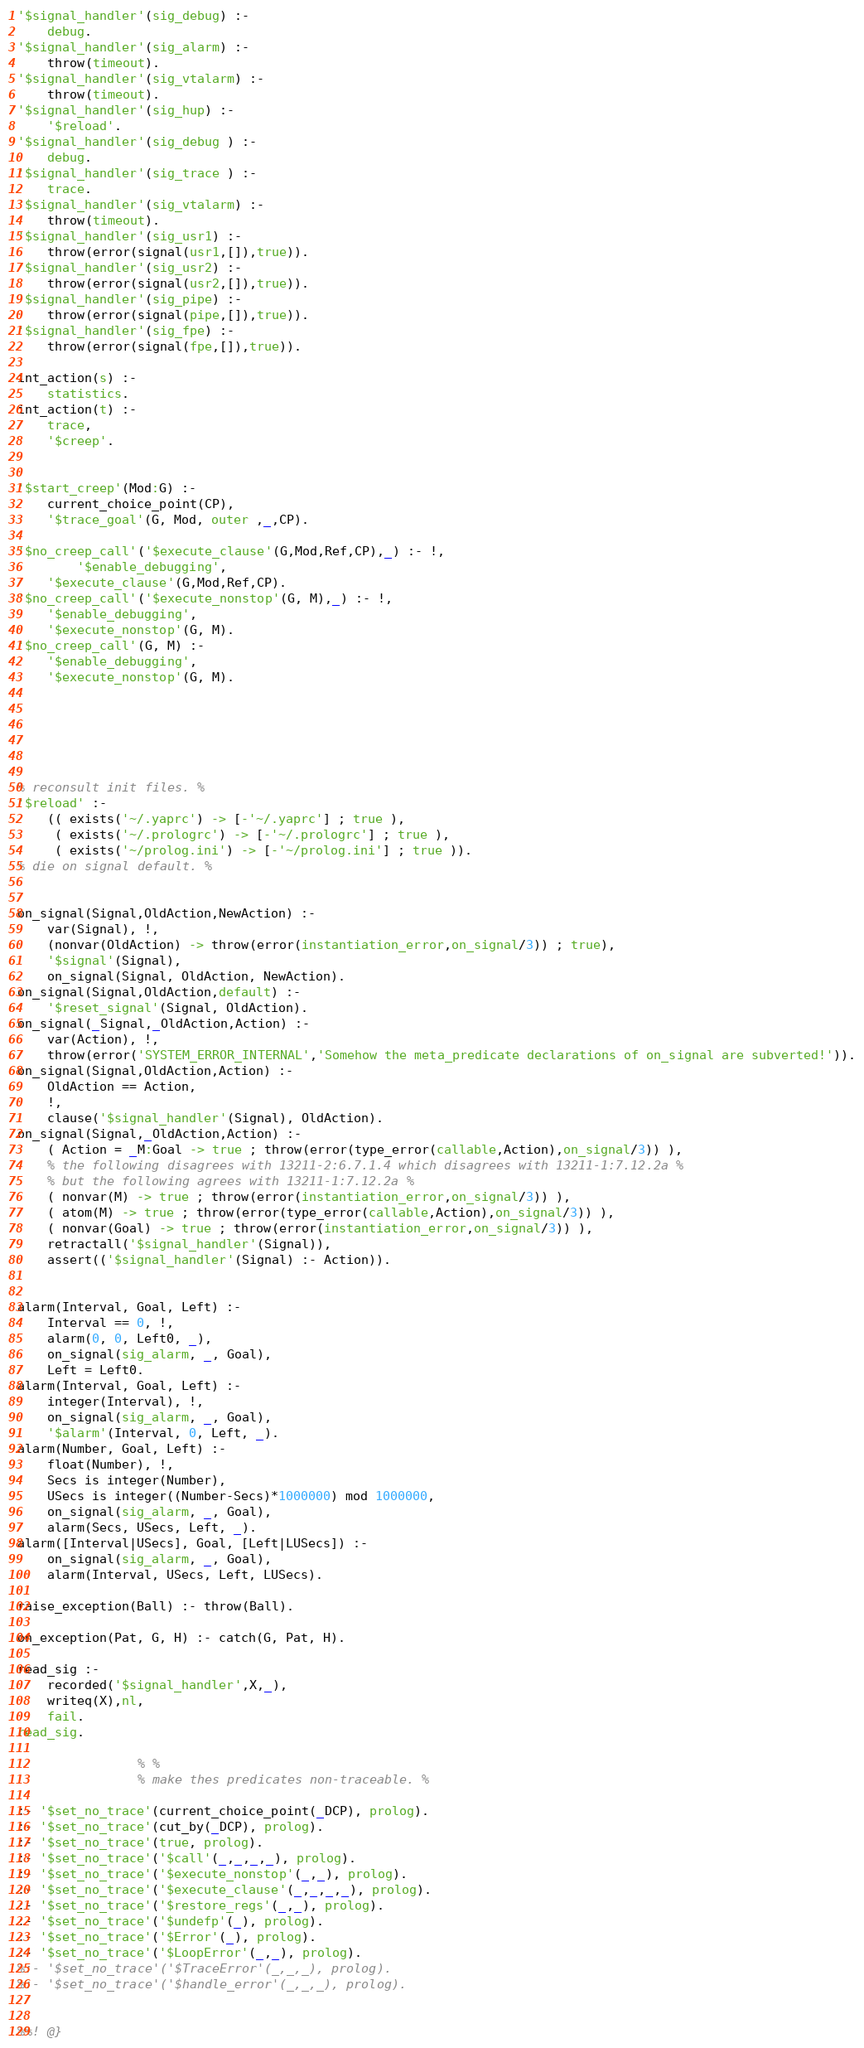<code> <loc_0><loc_0><loc_500><loc_500><_Prolog_>'$signal_handler'(sig_debug) :-
	debug.
'$signal_handler'(sig_alarm) :-
    throw(timeout).
'$signal_handler'(sig_vtalarm) :-
    throw(timeout).
'$signal_handler'(sig_hup) :-
    '$reload'.
'$signal_handler'(sig_debug ) :-
	debug.
'$signal_handler'(sig_trace ) :-
	trace.
'$signal_handler'(sig_vtalarm) :-
    throw(timeout).
'$signal_handler'(sig_usr1) :-
    throw(error(signal(usr1,[]),true)).
'$signal_handler'(sig_usr2) :-
    throw(error(signal(usr2,[]),true)).
'$signal_handler'(sig_pipe) :-
    throw(error(signal(pipe,[]),true)).
'$signal_handler'(sig_fpe) :-
    throw(error(signal(fpe,[]),true)).

int_action(s) :-
    statistics.
int_action(t) :-
    trace,
    '$creep'.


'$start_creep'(Mod:G) :-
    current_choice_point(CP),
    '$trace_goal'(G, Mod, outer ,_,CP).

'$no_creep_call'('$execute_clause'(G,Mod,Ref,CP),_) :- !,
        '$enable_debugging',
	'$execute_clause'(G,Mod,Ref,CP).
'$no_creep_call'('$execute_nonstop'(G, M),_) :- !,
	'$enable_debugging',
	'$execute_nonstop'(G, M).
'$no_creep_call'(G, M) :-
	'$enable_debugging',
	'$execute_nonstop'(G, M).






% reconsult init files. %
'$reload' :-
    (( exists('~/.yaprc') -> [-'~/.yaprc'] ; true ),
     ( exists('~/.prologrc') -> [-'~/.prologrc'] ; true ),
     ( exists('~/prolog.ini') -> [-'~/prolog.ini'] ; true )).
% die on signal default. %


on_signal(Signal,OldAction,NewAction) :-
    var(Signal), !,
    (nonvar(OldAction) -> throw(error(instantiation_error,on_signal/3)) ; true),
    '$signal'(Signal),
    on_signal(Signal, OldAction, NewAction).
on_signal(Signal,OldAction,default) :-
    '$reset_signal'(Signal, OldAction).
on_signal(_Signal,_OldAction,Action) :-
    var(Action), !,
    throw(error('SYSTEM_ERROR_INTERNAL','Somehow the meta_predicate declarations of on_signal are subverted!')).
on_signal(Signal,OldAction,Action) :-
    OldAction == Action,
    !,
    clause('$signal_handler'(Signal), OldAction).
on_signal(Signal,_OldAction,Action) :-
    ( Action = _M:Goal -> true ; throw(error(type_error(callable,Action),on_signal/3)) ),
    % the following disagrees with 13211-2:6.7.1.4 which disagrees with 13211-1:7.12.2a %
    % but the following agrees with 13211-1:7.12.2a %
    ( nonvar(M) -> true ; throw(error(instantiation_error,on_signal/3)) ),
    ( atom(M) -> true ; throw(error(type_error(callable,Action),on_signal/3)) ),
    ( nonvar(Goal) -> true ; throw(error(instantiation_error,on_signal/3)) ),
    retractall('$signal_handler'(Signal)),
    assert(('$signal_handler'(Signal) :- Action)).


alarm(Interval, Goal, Left) :-
	Interval == 0, !,
	alarm(0, 0, Left0, _),
	on_signal(sig_alarm, _, Goal),
	Left = Left0.
alarm(Interval, Goal, Left) :-
	integer(Interval), !,
	on_signal(sig_alarm, _, Goal),
	'$alarm'(Interval, 0, Left, _).
alarm(Number, Goal, Left) :-
	float(Number), !,
	Secs is integer(Number),
	USecs is integer((Number-Secs)*1000000) mod 1000000,
	on_signal(sig_alarm, _, Goal),
	alarm(Secs, USecs, Left, _).
alarm([Interval|USecs], Goal, [Left|LUSecs]) :-
	on_signal(sig_alarm, _, Goal),
	alarm(Interval, USecs, Left, LUSecs).

raise_exception(Ball) :- throw(Ball).

on_exception(Pat, G, H) :- catch(G, Pat, H).

read_sig :-
	recorded('$signal_handler',X,_),
	writeq(X),nl,
	fail.
read_sig.

				% %
				% make thes predicates non-traceable. %

:- '$set_no_trace'(current_choice_point(_DCP), prolog).
:- '$set_no_trace'(cut_by(_DCP), prolog).
:- '$set_no_trace'(true, prolog).
:- '$set_no_trace'('$call'(_,_,_,_), prolog).
:- '$set_no_trace'('$execute_nonstop'(_,_), prolog).
:- '$set_no_trace'('$execute_clause'(_,_,_,_), prolog).
:- '$set_no_trace'('$restore_regs'(_,_), prolog).
:- '$set_no_trace'('$undefp'(_), prolog).
:- '$set_no_trace'('$Error'(_), prolog).
:- '$set_no_trace'('$LoopError'(_,_), prolog).
%:- '$set_no_trace'('$TraceError'(_,_,_), prolog).
%:- '$set_no_trace'('$handle_error'(_,_,_), prolog).


%%! @}
</code> 